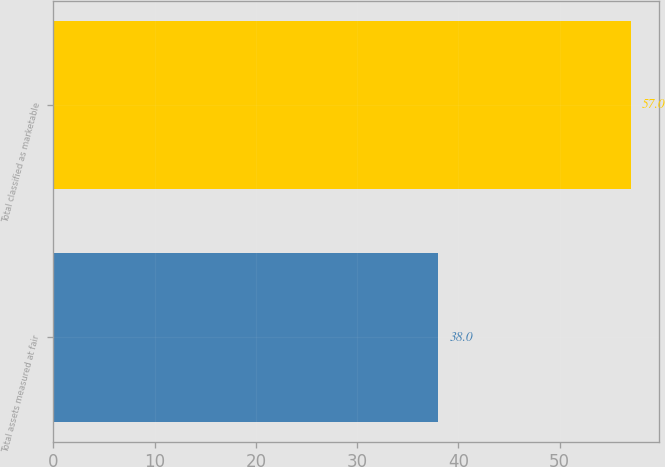Convert chart to OTSL. <chart><loc_0><loc_0><loc_500><loc_500><bar_chart><fcel>Total assets measured at fair<fcel>Total classified as marketable<nl><fcel>38<fcel>57<nl></chart> 